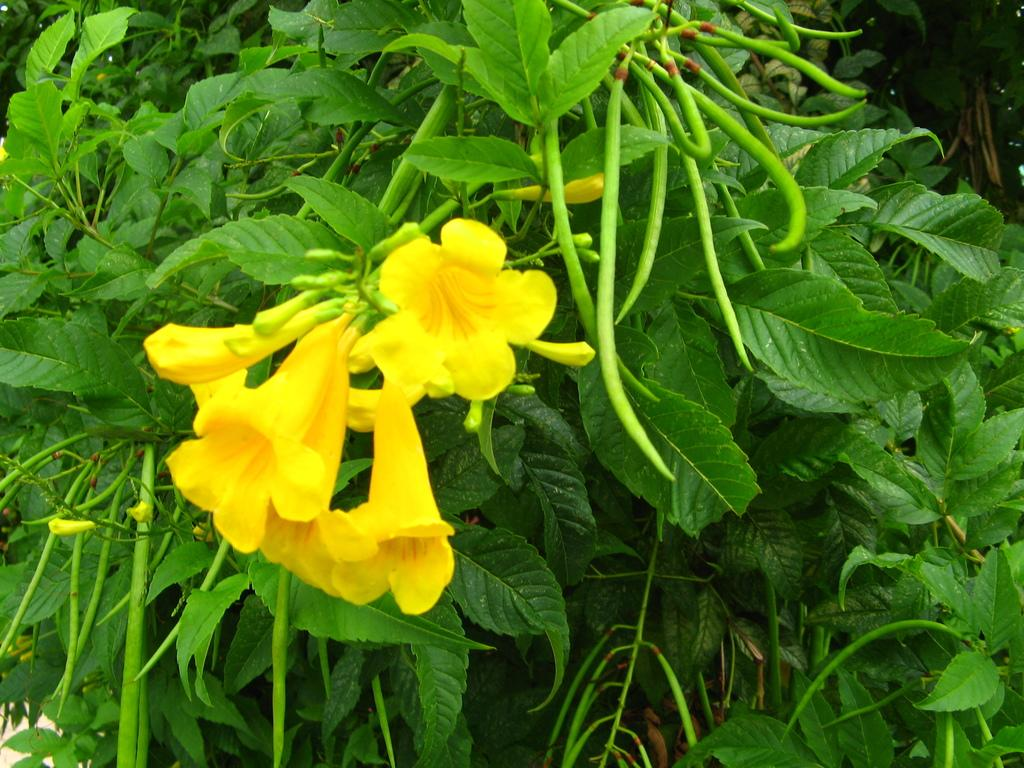What color are the flowers in the image? The flowers in the image are yellow. What color are the leaves in the image? The leaves in the image are green. What type of vegetable can be seen at the top of the image? There are green beans at the top of the image. Can you see any sea creatures in the image? There are no sea creatures present in the image; it features flowers, leaves, and green beans. What type of beast can be seen interacting with the flowers in the image? There is no beast present in the image; it only features flowers, leaves, and green beans. 